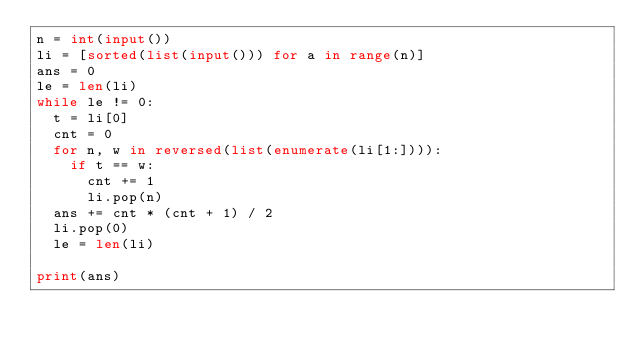Convert code to text. <code><loc_0><loc_0><loc_500><loc_500><_Python_>n = int(input())
li = [sorted(list(input())) for a in range(n)]
ans = 0
le = len(li)
while le != 0:
  t = li[0]
  cnt = 0
  for n, w in reversed(list(enumerate(li[1:]))):
    if t == w:
      cnt += 1
      li.pop(n)
  ans += cnt * (cnt + 1) / 2
  li.pop(0)
  le = len(li)

print(ans)</code> 